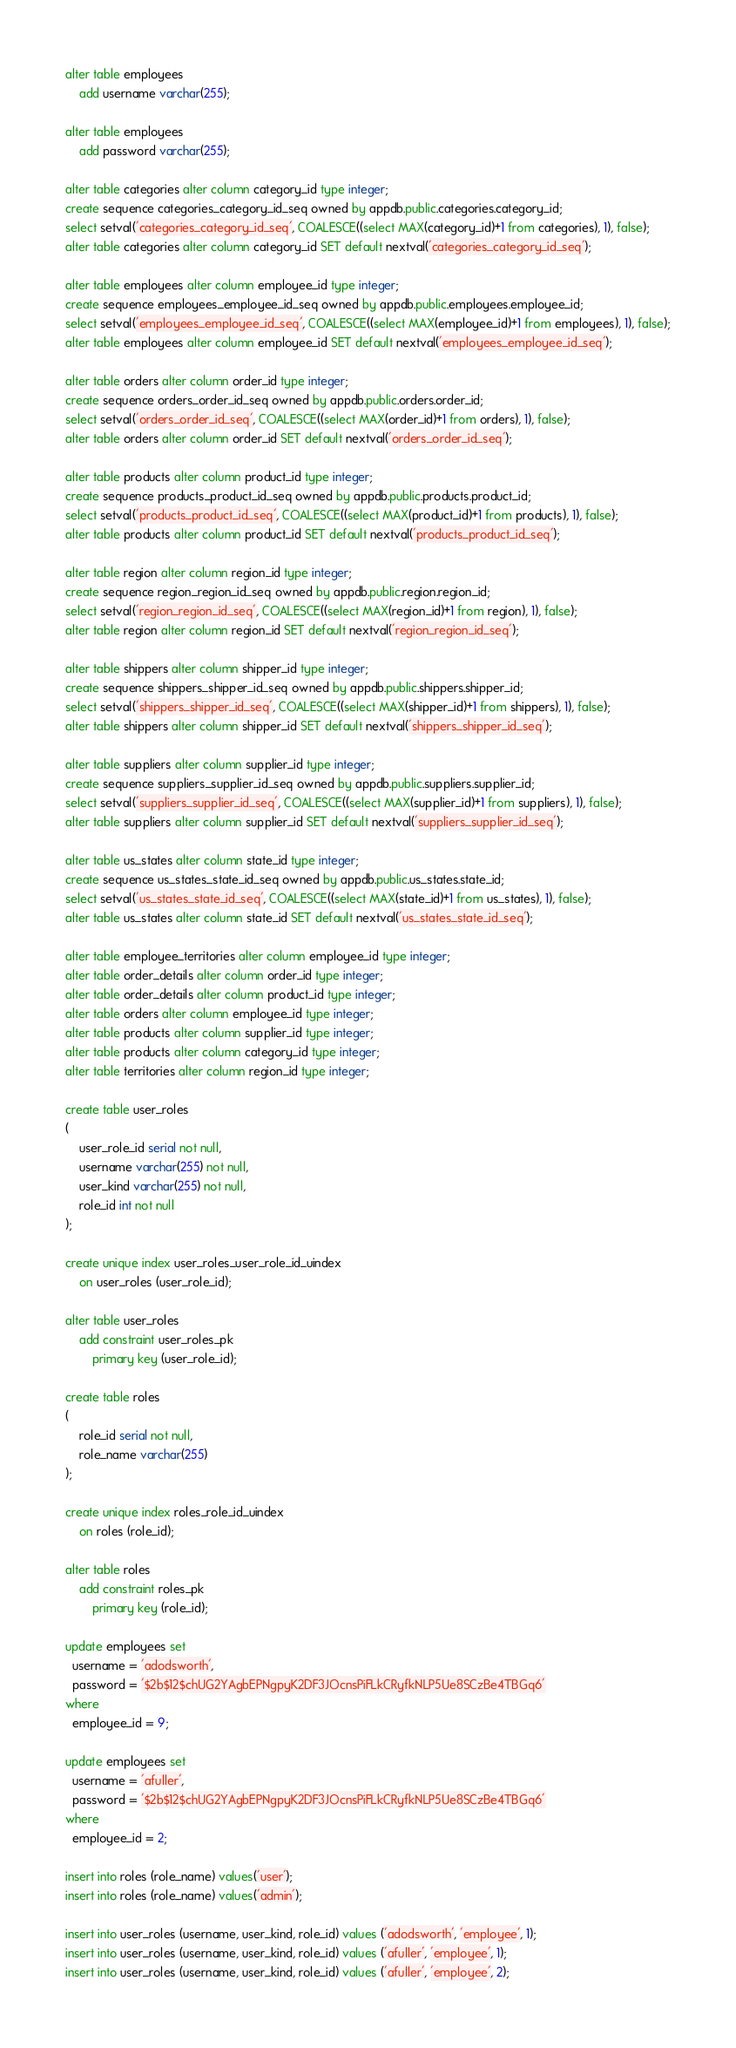Convert code to text. <code><loc_0><loc_0><loc_500><loc_500><_SQL_>alter table employees
	add username varchar(255);

alter table employees
	add password varchar(255);

alter table categories alter column category_id type integer;
create sequence categories_category_id_seq owned by appdb.public.categories.category_id;
select setval('categories_category_id_seq', COALESCE((select MAX(category_id)+1 from categories), 1), false);
alter table categories alter column category_id SET default nextval('categories_category_id_seq');

alter table employees alter column employee_id type integer;
create sequence employees_employee_id_seq owned by appdb.public.employees.employee_id;
select setval('employees_employee_id_seq', COALESCE((select MAX(employee_id)+1 from employees), 1), false);
alter table employees alter column employee_id SET default nextval('employees_employee_id_seq');

alter table orders alter column order_id type integer;
create sequence orders_order_id_seq owned by appdb.public.orders.order_id;
select setval('orders_order_id_seq', COALESCE((select MAX(order_id)+1 from orders), 1), false);
alter table orders alter column order_id SET default nextval('orders_order_id_seq');

alter table products alter column product_id type integer;
create sequence products_product_id_seq owned by appdb.public.products.product_id;
select setval('products_product_id_seq', COALESCE((select MAX(product_id)+1 from products), 1), false);
alter table products alter column product_id SET default nextval('products_product_id_seq');

alter table region alter column region_id type integer;
create sequence region_region_id_seq owned by appdb.public.region.region_id;
select setval('region_region_id_seq', COALESCE((select MAX(region_id)+1 from region), 1), false);
alter table region alter column region_id SET default nextval('region_region_id_seq');

alter table shippers alter column shipper_id type integer;
create sequence shippers_shipper_id_seq owned by appdb.public.shippers.shipper_id;
select setval('shippers_shipper_id_seq', COALESCE((select MAX(shipper_id)+1 from shippers), 1), false);
alter table shippers alter column shipper_id SET default nextval('shippers_shipper_id_seq');

alter table suppliers alter column supplier_id type integer;
create sequence suppliers_supplier_id_seq owned by appdb.public.suppliers.supplier_id;
select setval('suppliers_supplier_id_seq', COALESCE((select MAX(supplier_id)+1 from suppliers), 1), false);
alter table suppliers alter column supplier_id SET default nextval('suppliers_supplier_id_seq');

alter table us_states alter column state_id type integer;
create sequence us_states_state_id_seq owned by appdb.public.us_states.state_id;
select setval('us_states_state_id_seq', COALESCE((select MAX(state_id)+1 from us_states), 1), false);
alter table us_states alter column state_id SET default nextval('us_states_state_id_seq');

alter table employee_territories alter column employee_id type integer;
alter table order_details alter column order_id type integer;
alter table order_details alter column product_id type integer;
alter table orders alter column employee_id type integer;
alter table products alter column supplier_id type integer;
alter table products alter column category_id type integer;
alter table territories alter column region_id type integer;

create table user_roles
(
	user_role_id serial not null,
	username varchar(255) not null,
	user_kind varchar(255) not null,
	role_id int not null
);

create unique index user_roles_user_role_id_uindex
	on user_roles (user_role_id);

alter table user_roles
	add constraint user_roles_pk
		primary key (user_role_id);

create table roles
(
	role_id serial not null,
	role_name varchar(255)
);

create unique index roles_role_id_uindex
	on roles (role_id);

alter table roles
	add constraint roles_pk
		primary key (role_id);

update employees set
  username = 'adodsworth',
  password = '$2b$12$chUG2YAgbEPNgpyK2DF3JOcnsPiFLkCRyfkNLP5Ue8SCzBe4TBGq6'
where
  employee_id = 9;

update employees set
  username = 'afuller',
  password = '$2b$12$chUG2YAgbEPNgpyK2DF3JOcnsPiFLkCRyfkNLP5Ue8SCzBe4TBGq6'
where
  employee_id = 2;

insert into roles (role_name) values('user');
insert into roles (role_name) values('admin');

insert into user_roles (username, user_kind, role_id) values ('adodsworth', 'employee', 1);
insert into user_roles (username, user_kind, role_id) values ('afuller', 'employee', 1);
insert into user_roles (username, user_kind, role_id) values ('afuller', 'employee', 2);</code> 